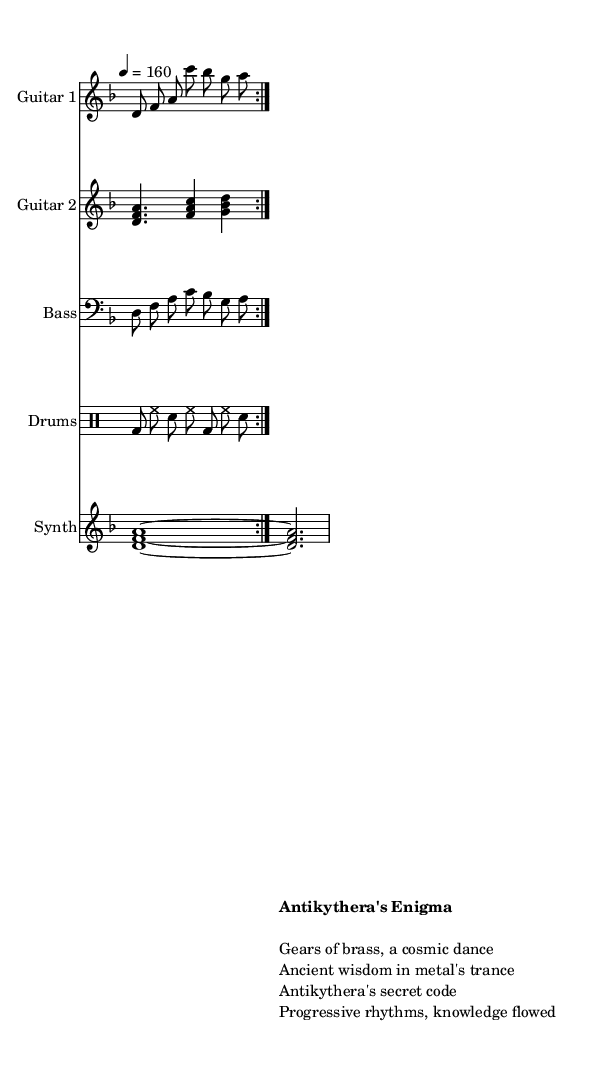What is the key signature of this music? The key signature is indicated by the absence of sharps or flats at the beginning of the staff, which corresponds to D minor.
Answer: D minor What is the time signature of this music? The time signature is specified at the beginning of the score as 7/8, indicating there are seven eighth notes per measure.
Answer: 7/8 What is the tempo marking in the score? The tempo marking is stated as 4 = 160, which means there are 160 beats per minute.
Answer: 160 How many instruments are featured in this score? The score includes five distinct parts: Guitar 1, Guitar 2, Bass, Drums, and Synth, making a total of five instruments.
Answer: Five What are the names of the two guitars as labeled in the score? The two guitars are labeled as Guitar 1 and Guitar 2, each with its respective musical line.
Answer: Guitar 1 and Guitar 2 What musical style is represented in this piece? The composition is characterized as Progressive Metal, indicated by the complexity and structure of the arrangements and the thematic content surrounding ancient technologies.
Answer: Progressive Metal What theme does the title "Antikythera's Enigma" suggest? The title suggests a connection to the ancient Antikythera mechanism, implying themes of lost ancient technologies and knowledge in the musical narrative.
Answer: Lost ancient technologies 